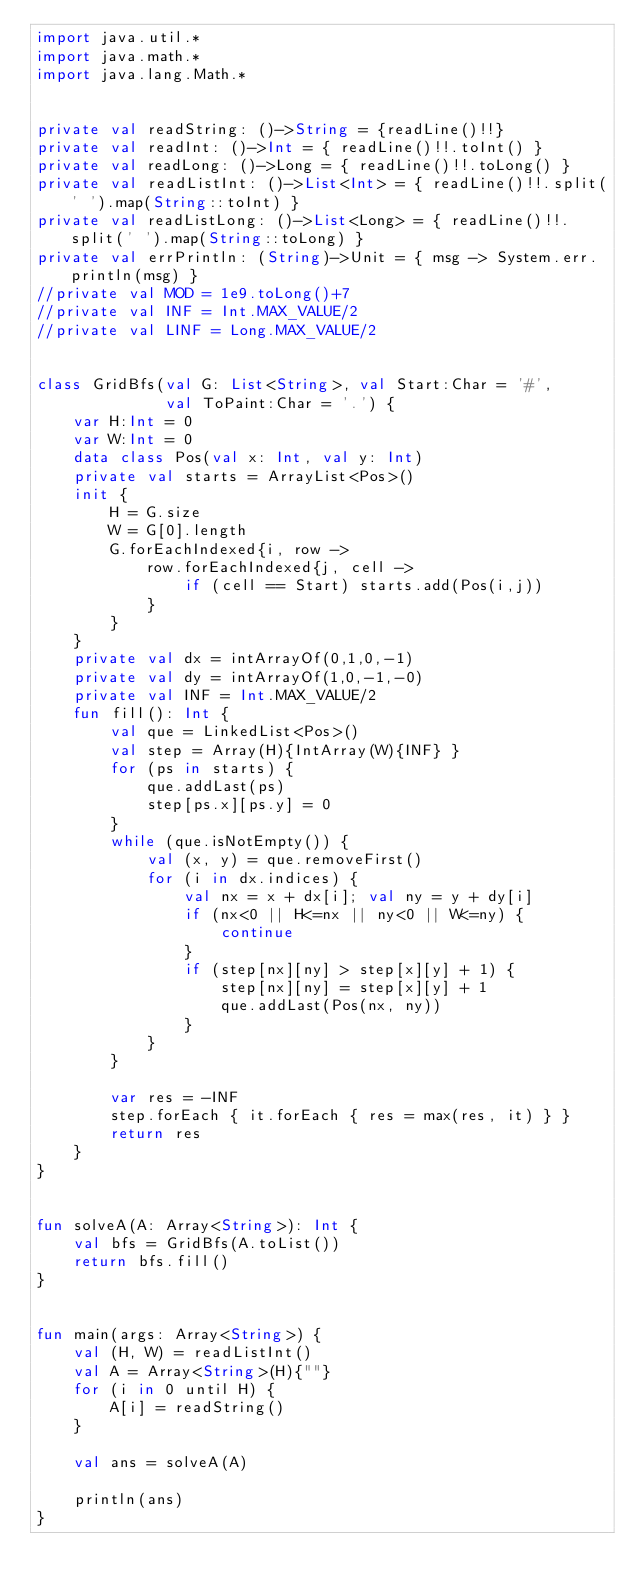<code> <loc_0><loc_0><loc_500><loc_500><_Kotlin_>import java.util.*
import java.math.*
import java.lang.Math.*


private val readString: ()->String = {readLine()!!}
private val readInt: ()->Int = { readLine()!!.toInt() }
private val readLong: ()->Long = { readLine()!!.toLong() }
private val readListInt: ()->List<Int> = { readLine()!!.split(' ').map(String::toInt) }
private val readListLong: ()->List<Long> = { readLine()!!.split(' ').map(String::toLong) }
private val errPrintln: (String)->Unit = { msg -> System.err.println(msg) }
//private val MOD = 1e9.toLong()+7
//private val INF = Int.MAX_VALUE/2
//private val LINF = Long.MAX_VALUE/2


class GridBfs(val G: List<String>, val Start:Char = '#',
              val ToPaint:Char = '.') {
    var H:Int = 0
    var W:Int = 0
    data class Pos(val x: Int, val y: Int)
    private val starts = ArrayList<Pos>()
    init {
        H = G.size
        W = G[0].length
        G.forEachIndexed{i, row ->
            row.forEachIndexed{j, cell ->
                if (cell == Start) starts.add(Pos(i,j))
            }
        }
    }
    private val dx = intArrayOf(0,1,0,-1)
    private val dy = intArrayOf(1,0,-1,-0)
    private val INF = Int.MAX_VALUE/2
    fun fill(): Int {
        val que = LinkedList<Pos>()
        val step = Array(H){IntArray(W){INF} }
        for (ps in starts) {
            que.addLast(ps)
            step[ps.x][ps.y] = 0
        }
        while (que.isNotEmpty()) {
            val (x, y) = que.removeFirst()
            for (i in dx.indices) {
                val nx = x + dx[i]; val ny = y + dy[i]
                if (nx<0 || H<=nx || ny<0 || W<=ny) {
                    continue
                }
                if (step[nx][ny] > step[x][y] + 1) {
                    step[nx][ny] = step[x][y] + 1
                    que.addLast(Pos(nx, ny))
                }
            }
        }

        var res = -INF
        step.forEach { it.forEach { res = max(res, it) } }
        return res
    }
}


fun solveA(A: Array<String>): Int {
    val bfs = GridBfs(A.toList())
    return bfs.fill()
}


fun main(args: Array<String>) {
    val (H, W) = readListInt()
    val A = Array<String>(H){""}
    for (i in 0 until H) {
        A[i] = readString()
    }

    val ans = solveA(A)

    println(ans)
}
</code> 